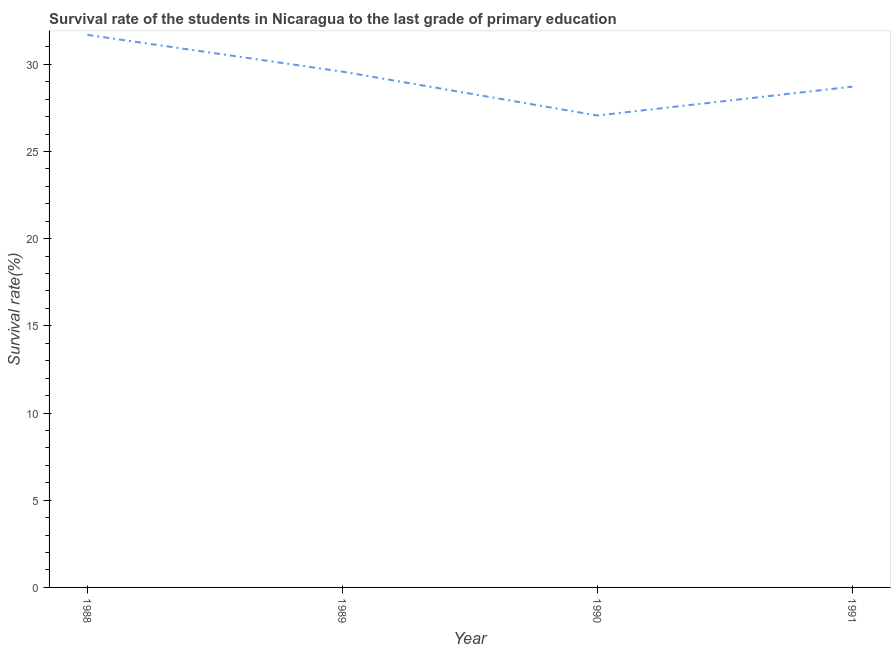What is the survival rate in primary education in 1990?
Keep it short and to the point. 27.06. Across all years, what is the maximum survival rate in primary education?
Offer a terse response. 31.69. Across all years, what is the minimum survival rate in primary education?
Provide a succinct answer. 27.06. In which year was the survival rate in primary education minimum?
Provide a short and direct response. 1990. What is the sum of the survival rate in primary education?
Provide a short and direct response. 117.04. What is the difference between the survival rate in primary education in 1990 and 1991?
Ensure brevity in your answer.  -1.65. What is the average survival rate in primary education per year?
Your response must be concise. 29.26. What is the median survival rate in primary education?
Ensure brevity in your answer.  29.15. In how many years, is the survival rate in primary education greater than 20 %?
Offer a very short reply. 4. What is the ratio of the survival rate in primary education in 1989 to that in 1991?
Ensure brevity in your answer.  1.03. Is the difference between the survival rate in primary education in 1988 and 1989 greater than the difference between any two years?
Your response must be concise. No. What is the difference between the highest and the second highest survival rate in primary education?
Provide a succinct answer. 2.11. What is the difference between the highest and the lowest survival rate in primary education?
Your answer should be very brief. 4.62. Does the survival rate in primary education monotonically increase over the years?
Your answer should be compact. No. What is the title of the graph?
Provide a short and direct response. Survival rate of the students in Nicaragua to the last grade of primary education. What is the label or title of the X-axis?
Ensure brevity in your answer.  Year. What is the label or title of the Y-axis?
Ensure brevity in your answer.  Survival rate(%). What is the Survival rate(%) of 1988?
Your response must be concise. 31.69. What is the Survival rate(%) of 1989?
Your answer should be very brief. 29.58. What is the Survival rate(%) of 1990?
Provide a succinct answer. 27.06. What is the Survival rate(%) of 1991?
Keep it short and to the point. 28.72. What is the difference between the Survival rate(%) in 1988 and 1989?
Your response must be concise. 2.11. What is the difference between the Survival rate(%) in 1988 and 1990?
Offer a terse response. 4.62. What is the difference between the Survival rate(%) in 1988 and 1991?
Give a very brief answer. 2.97. What is the difference between the Survival rate(%) in 1989 and 1990?
Your answer should be compact. 2.51. What is the difference between the Survival rate(%) in 1989 and 1991?
Provide a succinct answer. 0.86. What is the difference between the Survival rate(%) in 1990 and 1991?
Offer a very short reply. -1.65. What is the ratio of the Survival rate(%) in 1988 to that in 1989?
Offer a terse response. 1.07. What is the ratio of the Survival rate(%) in 1988 to that in 1990?
Your answer should be very brief. 1.17. What is the ratio of the Survival rate(%) in 1988 to that in 1991?
Give a very brief answer. 1.1. What is the ratio of the Survival rate(%) in 1989 to that in 1990?
Provide a succinct answer. 1.09. What is the ratio of the Survival rate(%) in 1990 to that in 1991?
Offer a very short reply. 0.94. 